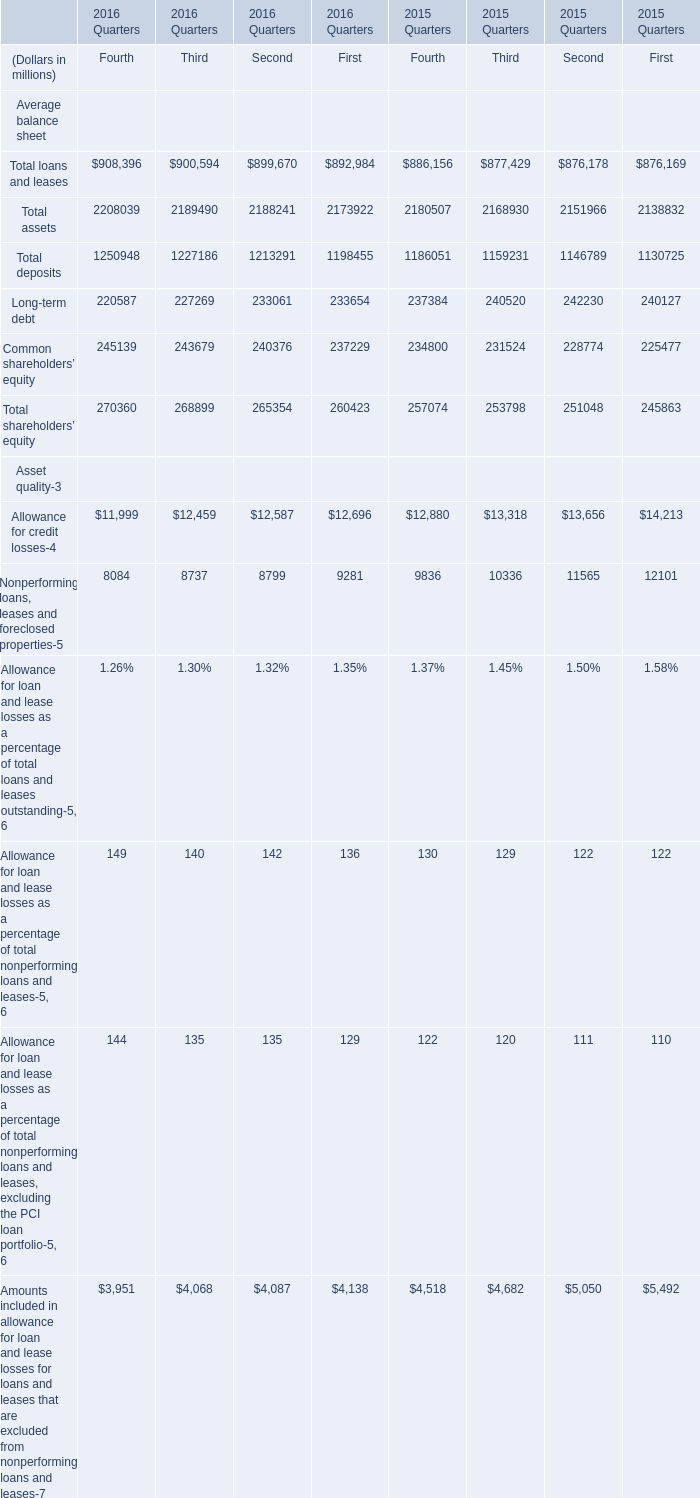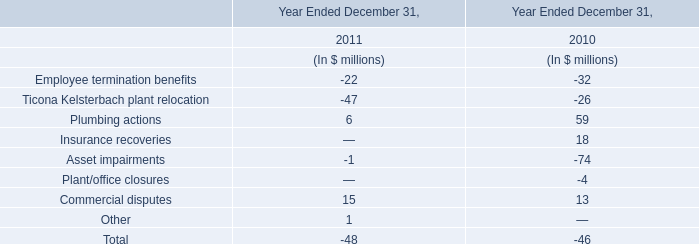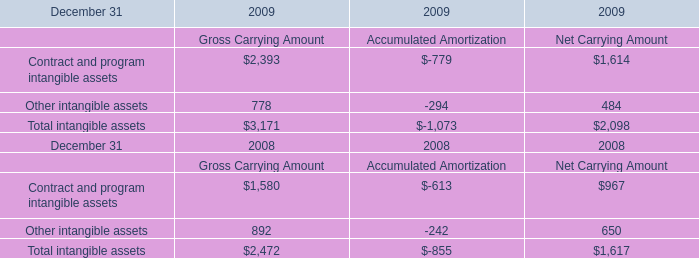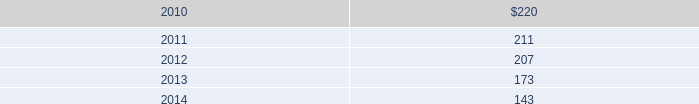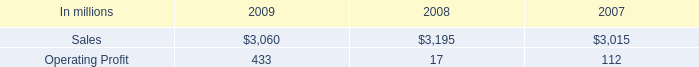What's the difference of Total assets between 2015 and 2016? (in million) 
Computations: ((((2208039 + 2189490) + 2188241) + 2173922) - (((2180507 + 2168930) + 2151966) + 2138832))
Answer: 119457.0. 